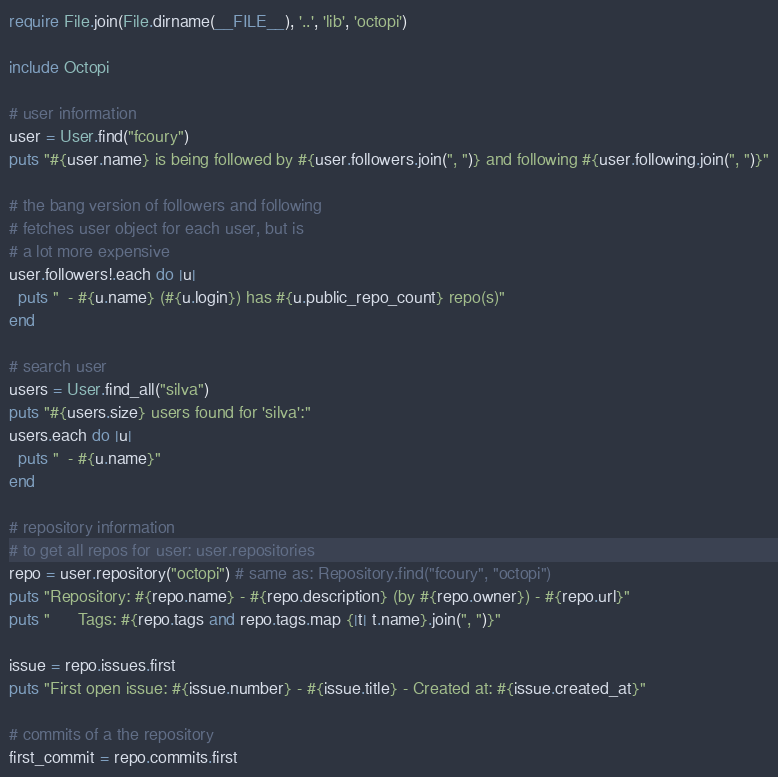<code> <loc_0><loc_0><loc_500><loc_500><_Ruby_>require File.join(File.dirname(__FILE__), '..', 'lib', 'octopi')

include Octopi

# user information
user = User.find("fcoury")
puts "#{user.name} is being followed by #{user.followers.join(", ")} and following #{user.following.join(", ")}"

# the bang version of followers and following 
# fetches user object for each user, but is 
# a lot more expensive
user.followers!.each do |u|
  puts "  - #{u.name} (#{u.login}) has #{u.public_repo_count} repo(s)"
end

# search user
users = User.find_all("silva")
puts "#{users.size} users found for 'silva':"
users.each do |u|
  puts "  - #{u.name}"
end

# repository information
# to get all repos for user: user.repositories
repo = user.repository("octopi") # same as: Repository.find("fcoury", "octopi")
puts "Repository: #{repo.name} - #{repo.description} (by #{repo.owner}) - #{repo.url}"
puts "      Tags: #{repo.tags and repo.tags.map {|t| t.name}.join(", ")}"

issue = repo.issues.first
puts "First open issue: #{issue.number} - #{issue.title} - Created at: #{issue.created_at}"

# commits of a the repository
first_commit = repo.commits.first</code> 